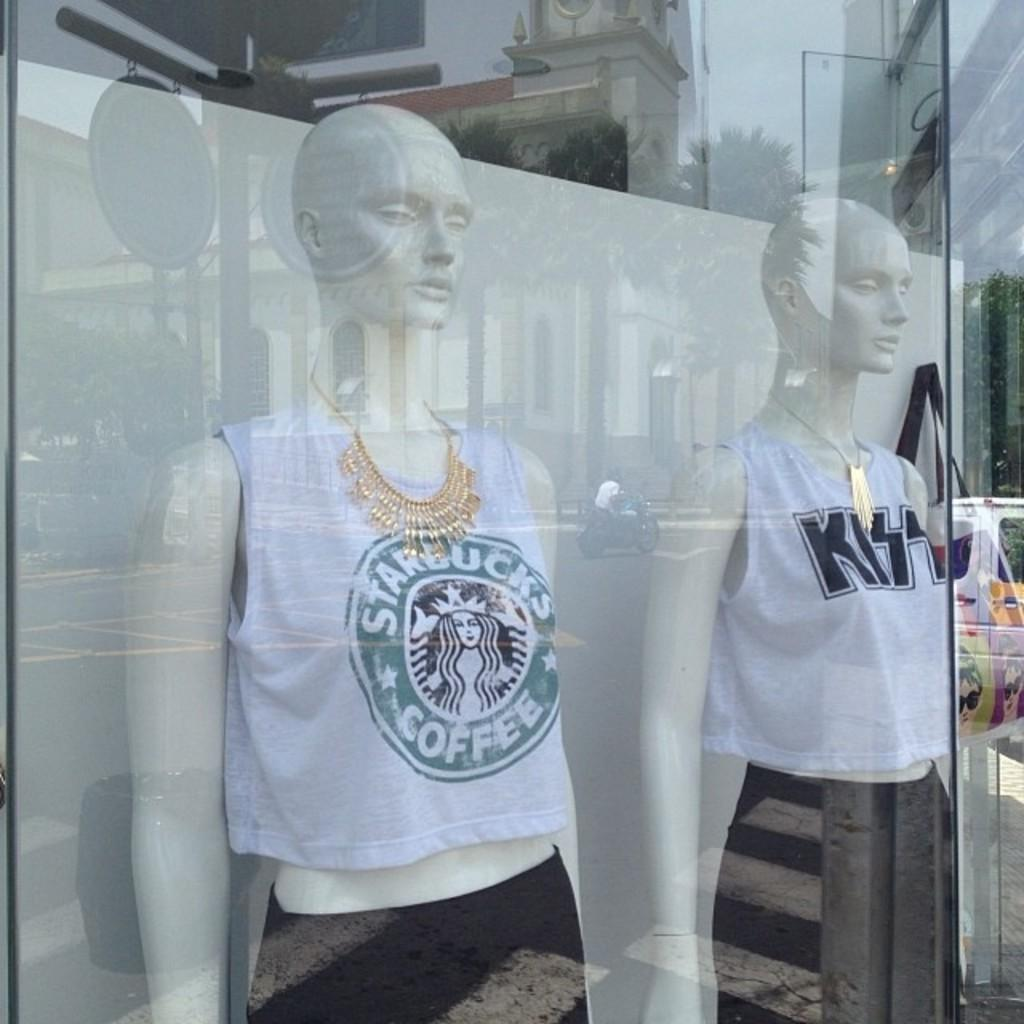<image>
Provide a brief description of the given image. A store manikin with a Starbucks coffee shirt on 